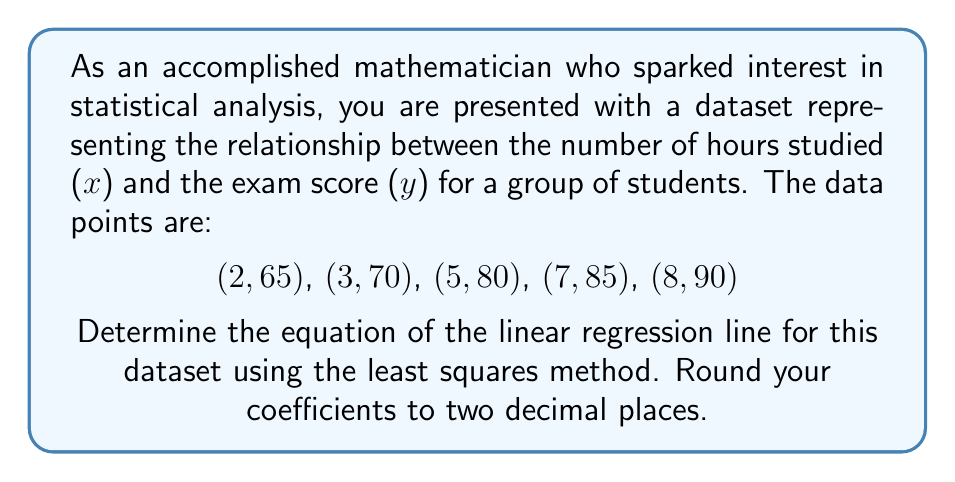Solve this math problem. To find the equation of the regression line, we'll use the formula:

$$y = mx + b$$

Where $m$ is the slope and $b$ is the y-intercept. We'll use the least squares method to find these values.

1) First, calculate the means of x and y:
   $$\bar{x} = \frac{2+3+5+7+8}{5} = 5$$
   $$\bar{y} = \frac{65+70+80+85+90}{5} = 78$$

2) Calculate the following sums:
   $$\sum (x - \bar{x})(y - \bar{y}) = (-3)(-13) + (-2)(-8) + (0)(2) + (2)(7) + (3)(12) = 78$$
   $$\sum (x - \bar{x})^2 = (-3)^2 + (-2)^2 + (0)^2 + (2)^2 + (3)^2 = 26$$

3) Calculate the slope (m):
   $$m = \frac{\sum (x - \bar{x})(y - \bar{y})}{\sum (x - \bar{x})^2} = \frac{78}{26} = 3$$

4) Calculate the y-intercept (b):
   $$b = \bar{y} - m\bar{x} = 78 - 3(5) = 63$$

5) Therefore, the equation of the regression line is:
   $$y = 3x + 63$$

Rounding coefficients to two decimal places:
$$y = 3.00x + 63.00$$
Answer: The equation of the linear regression line is: $y = 3.00x + 63.00$ 